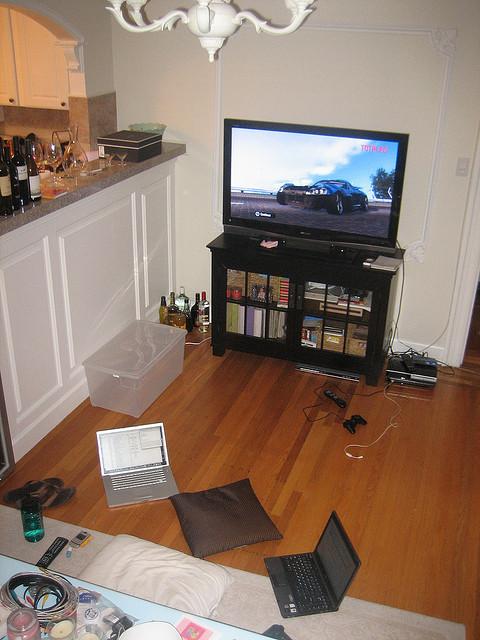Is there a laptop on the floor?
Give a very brief answer. Yes. Is there a plastic box on the floor?
Be succinct. Yes. What is on the t.v.?
Keep it brief. Car. 